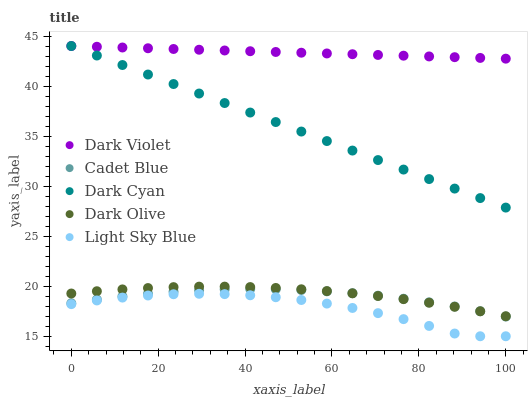Does Light Sky Blue have the minimum area under the curve?
Answer yes or no. Yes. Does Dark Violet have the maximum area under the curve?
Answer yes or no. Yes. Does Cadet Blue have the minimum area under the curve?
Answer yes or no. No. Does Cadet Blue have the maximum area under the curve?
Answer yes or no. No. Is Dark Cyan the smoothest?
Answer yes or no. Yes. Is Light Sky Blue the roughest?
Answer yes or no. Yes. Is Cadet Blue the smoothest?
Answer yes or no. No. Is Cadet Blue the roughest?
Answer yes or no. No. Does Light Sky Blue have the lowest value?
Answer yes or no. Yes. Does Cadet Blue have the lowest value?
Answer yes or no. No. Does Dark Violet have the highest value?
Answer yes or no. Yes. Does Cadet Blue have the highest value?
Answer yes or no. No. Is Dark Olive less than Dark Cyan?
Answer yes or no. Yes. Is Dark Violet greater than Dark Olive?
Answer yes or no. Yes. Does Dark Violet intersect Dark Cyan?
Answer yes or no. Yes. Is Dark Violet less than Dark Cyan?
Answer yes or no. No. Is Dark Violet greater than Dark Cyan?
Answer yes or no. No. Does Dark Olive intersect Dark Cyan?
Answer yes or no. No. 